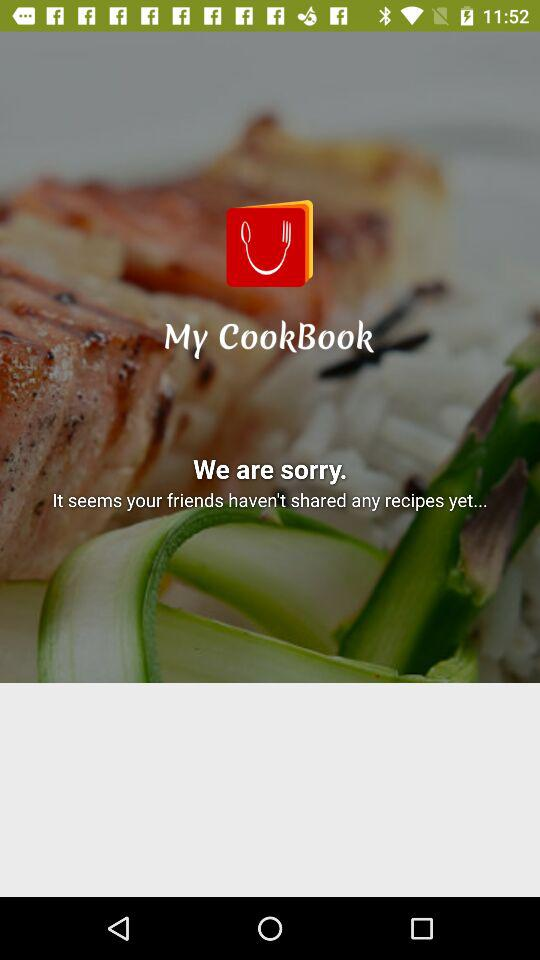What is the application name? The application name is "My CookBook". 